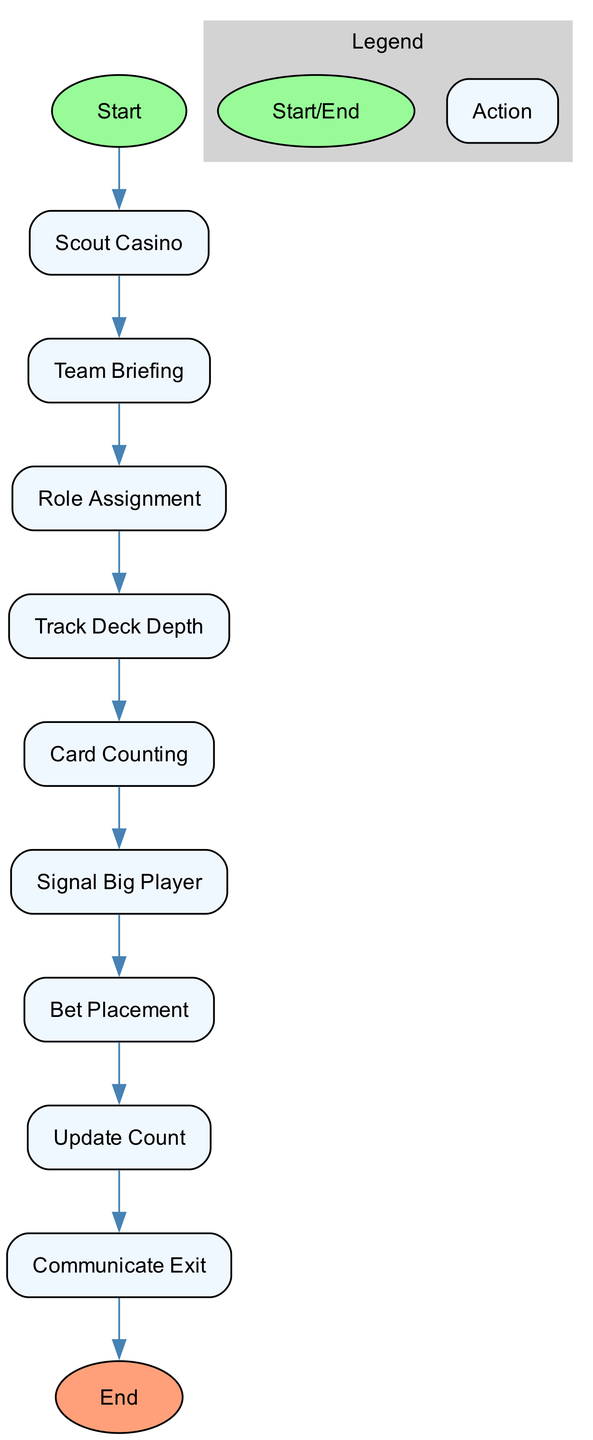What is the first action in the diagram? The first action is 'Scout Casino', which is the first node after the start.
Answer: Scout Casino How many actions are depicted in the diagram? There are 9 actions listed in total, counted from the start to the end of the diagram.
Answer: 9 Which action follows 'Team Briefing'? 'Role Assignment' is the action that comes immediately after 'Team Briefing' in the sequence of actions.
Answer: Role Assignment What role is assigned to team members? The roles assigned are 'Spotter', 'Controller', and 'Big Player', as stated in the 'Role Assignment' action.
Answer: Spotter, Controller, Big Player What is the final action in the sequence? The final action is 'Regroup and Analyze', which is the end node of the diagram.
Answer: Regroup and Analyze Which action involves real-time tracking of the deck? 'Track Deck Depth' involves the spotters tracking the depth of the deck in real-time.
Answer: Track Deck Depth How do Spotters communicate favorable counts? Spotters communicate favorable counts to the Big Player using a specific signal mentioned in the 'Signal Big Player' action.
Answer: Signal Big Player What does the Controller do at the end of the operation? The Controller decides when to wrap up the operation, indicated by the 'Communicate Exit' action.
Answer: Communicate Exit What indicates a favorable betting opportunity for the Big Player? The 'Signal Big Player' action indicates a favorable betting opportunity when the spotter gives a specific signal based on the count.
Answer: Signal Big Player 